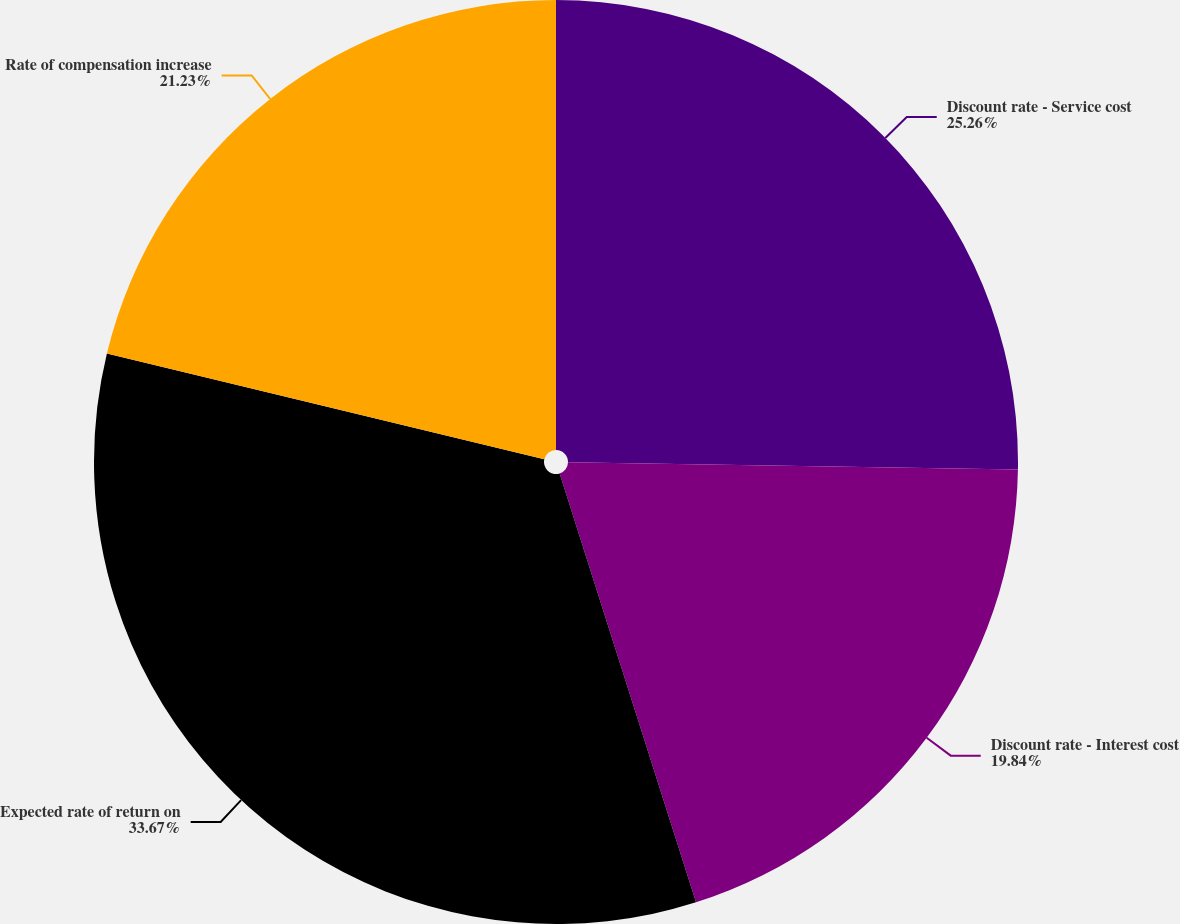<chart> <loc_0><loc_0><loc_500><loc_500><pie_chart><fcel>Discount rate - Service cost<fcel>Discount rate - Interest cost<fcel>Expected rate of return on<fcel>Rate of compensation increase<nl><fcel>25.26%<fcel>19.84%<fcel>33.67%<fcel>21.23%<nl></chart> 